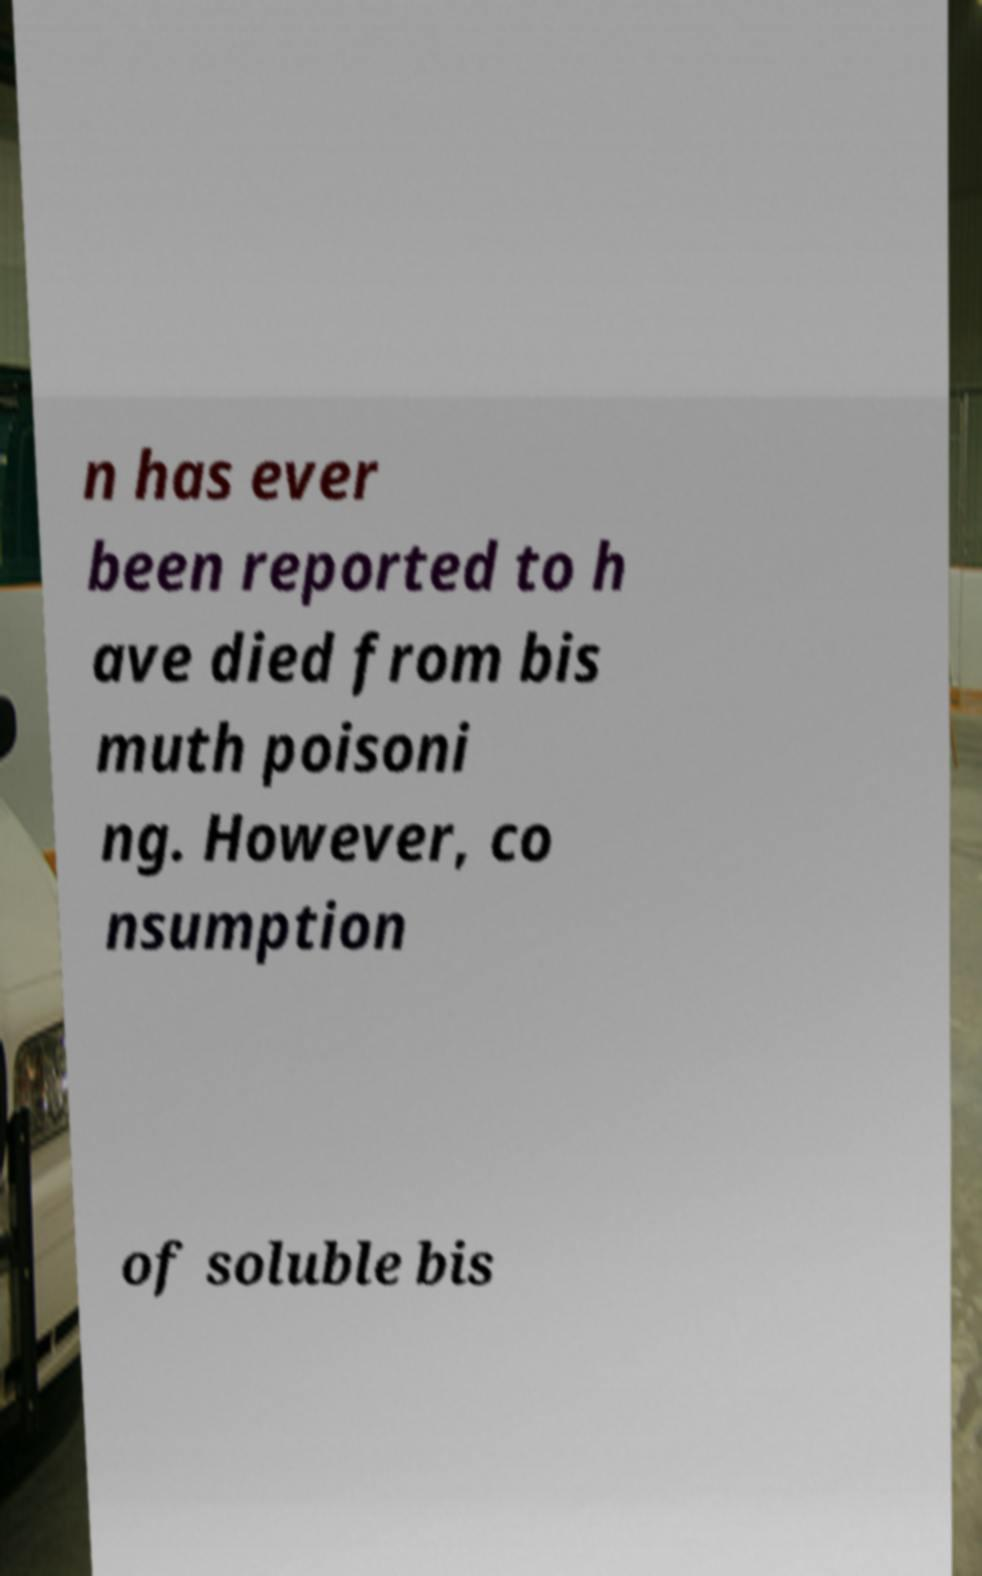What messages or text are displayed in this image? I need them in a readable, typed format. n has ever been reported to h ave died from bis muth poisoni ng. However, co nsumption of soluble bis 